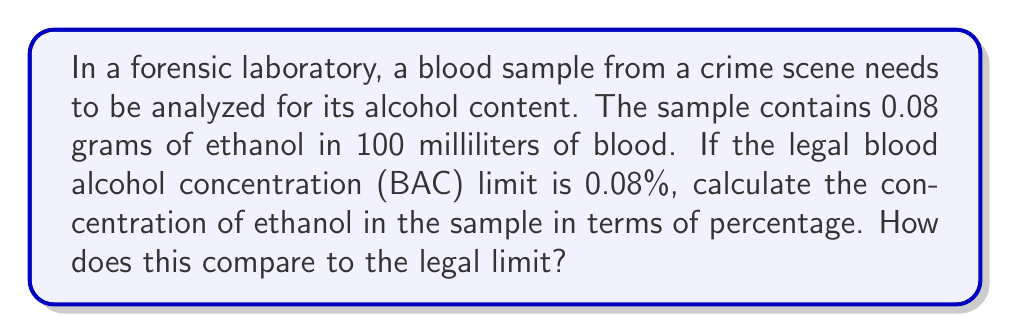What is the answer to this math problem? Let's approach this step-by-step:

1) First, we need to understand what blood alcohol concentration (BAC) means:
   BAC is typically expressed as the weight of ethanol in grams per 100 milliliters of blood.

2) We're given that the sample contains 0.08 grams of ethanol in 100 milliliters of blood.

3) To convert this to a percentage, we use the following formula:
   $$ \text{BAC}(\%) = \frac{\text{grams of ethanol}}{\text{milliliters of blood}} \times 100 $$

4) Plugging in our values:
   $$ \text{BAC}(\%) = \frac{0.08 \text{ g}}{100 \text{ mL}} \times 100 $$

5) Simplifying:
   $$ \text{BAC}(\%) = 0.08\% $$

6) Comparing to the legal limit:
   The calculated BAC (0.08%) is exactly equal to the legal limit (0.08%).
Answer: 0.08%; equal to legal limit 